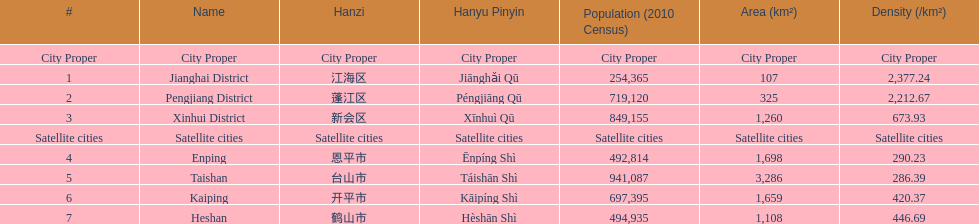What are the names of all the city proper districts? Jianghai District, Pengjiang District, Xinhui District. Among those districts, what is the value of their area (km2)? 107, 325, 1,260. Which district has the smallest area value? Jianghai District. 